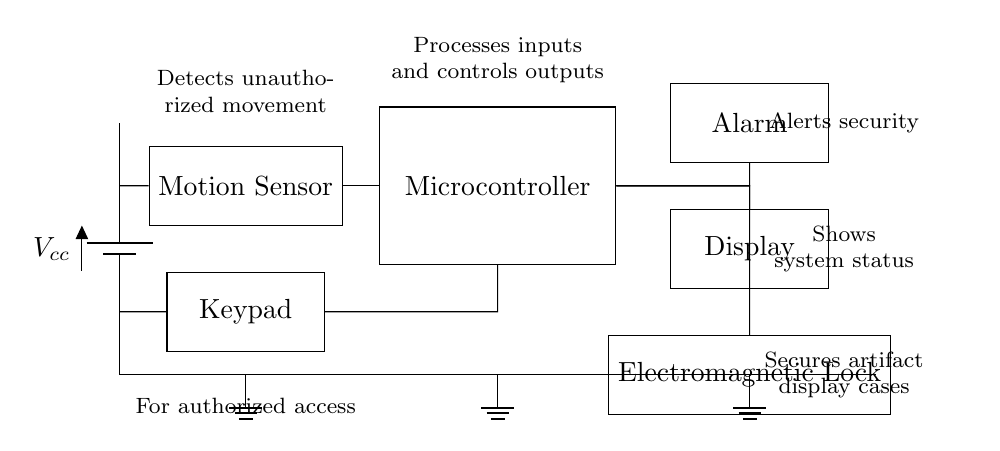What is the main component that detects movement? The circuit includes a motion sensor, indicated on the diagram, which specifically has the role of detecting unauthorized movement near the valuable artifacts.
Answer: Motion Sensor What does the microcontroller do? The microcontroller processes inputs from the motion sensor and keypad, controls the outputs, and manages the overall security functions of the system, as shown by its connections to other components in the circuit.
Answer: Processes inputs and controls outputs How does the system alert security? The circuit includes an alarm connected to the microcontroller, which activates when unauthorized movement is detected. This is indicated by the directional wiring from the microcontroller to the alarm component.
Answer: Alarm What is used to secure the artifact display cases? An electromagnetic lock is employed to secure the display cases, as illustrated in the circuit, showing its direct connection to the microcontroller which controls its operation.
Answer: Electromagnetic Lock How many components are connected to the microcontroller? There are three components connected to the microcontroller: the motion sensor, keypad, and alarm. This can be determined by counting the connections depicted in the circuit leading to the microcontroller.
Answer: Three What type of sensor is used in this circuit? The sensor type used is a motion sensor, necessary for detecting unauthorized presence, as labeled clearly in the circuit diagram.
Answer: Motion Sensor 